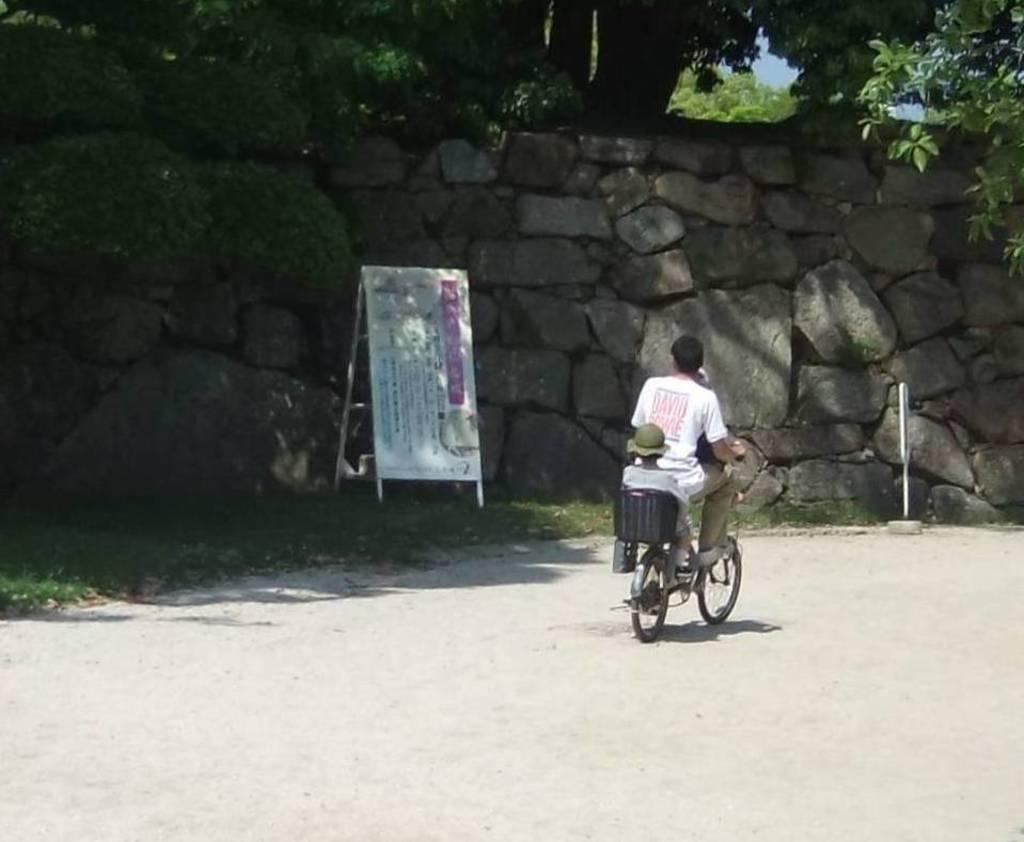How would you summarize this image in a sentence or two? In this image I can see the person riding the bicycle. To the left of him there is a board. And I can also see some trees and the rock. 